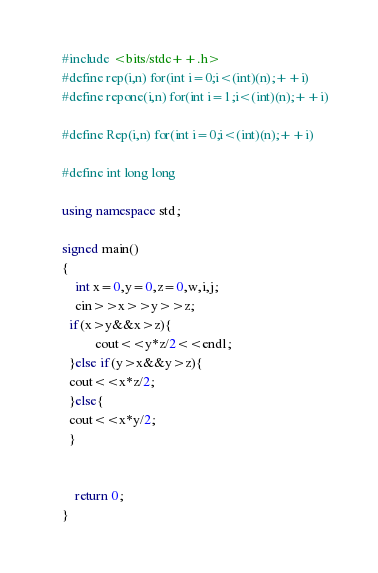Convert code to text. <code><loc_0><loc_0><loc_500><loc_500><_C++_>    #include <bits/stdc++.h>
    #define rep(i,n) for(int i=0;i<(int)(n);++i)
    #define repone(i,n) for(int i=1;i<(int)(n);++i)

    #define Rep(i,n) for(int i=0;i<(int)(n);++i)

    #define int long long

    using namespace std;

    signed main()
    {
        int x=0,y=0,z=0,w,i,j;
        cin>>x>>y>>z;
      if(x>y&&x>z){
              cout<<y*z/2<<endl;
      }else if(y>x&&y>z){
      cout<<x*z/2;
      }else{
      cout<<x*y/2;
      }


        return 0;
    }
</code> 